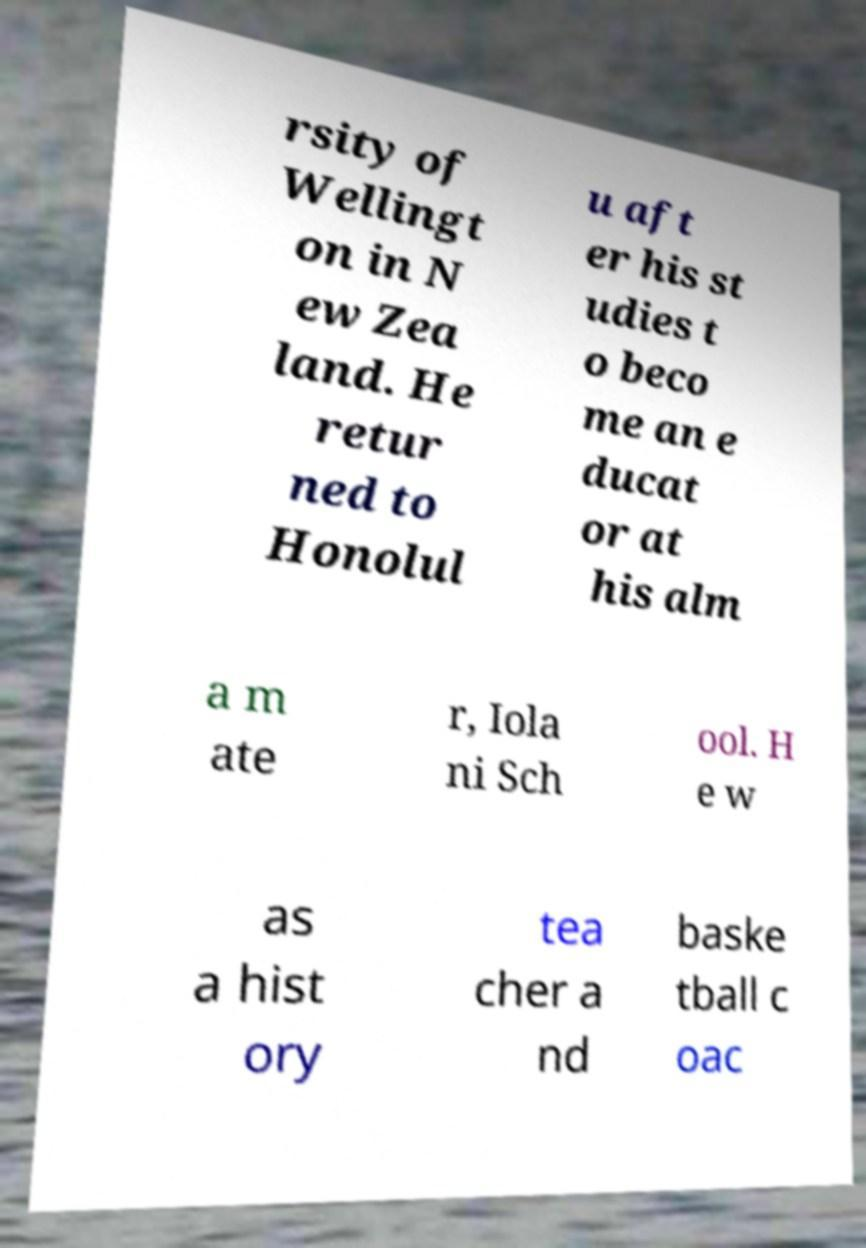For documentation purposes, I need the text within this image transcribed. Could you provide that? rsity of Wellingt on in N ew Zea land. He retur ned to Honolul u aft er his st udies t o beco me an e ducat or at his alm a m ate r, Iola ni Sch ool. H e w as a hist ory tea cher a nd baske tball c oac 